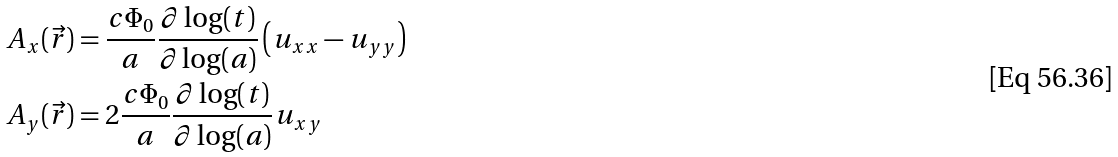Convert formula to latex. <formula><loc_0><loc_0><loc_500><loc_500>A _ { x } ( \vec { r } ) & = \frac { c \Phi _ { 0 } } { a } \frac { \partial \log ( t ) } { \partial \log ( a ) } \left ( u _ { x x } - u _ { y y } \right ) \\ A _ { y } ( \vec { r } ) & = 2 \frac { c \Phi _ { 0 } } { a } \frac { \partial \log ( t ) } { \partial \log ( a ) } u _ { x y }</formula> 